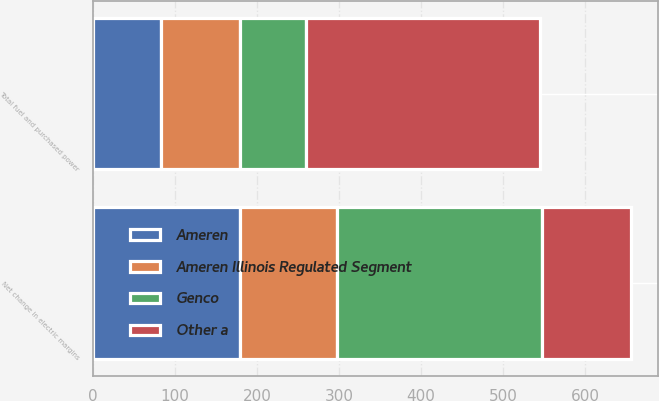Convert chart to OTSL. <chart><loc_0><loc_0><loc_500><loc_500><stacked_bar_chart><ecel><fcel>Total fuel and purchased power<fcel>Net change in electric margins<nl><fcel>Genco<fcel>80<fcel>250<nl><fcel>Ameren<fcel>83<fcel>179<nl><fcel>Ameren Illinois Regulated Segment<fcel>96<fcel>118<nl><fcel>Other a<fcel>286<fcel>109<nl></chart> 